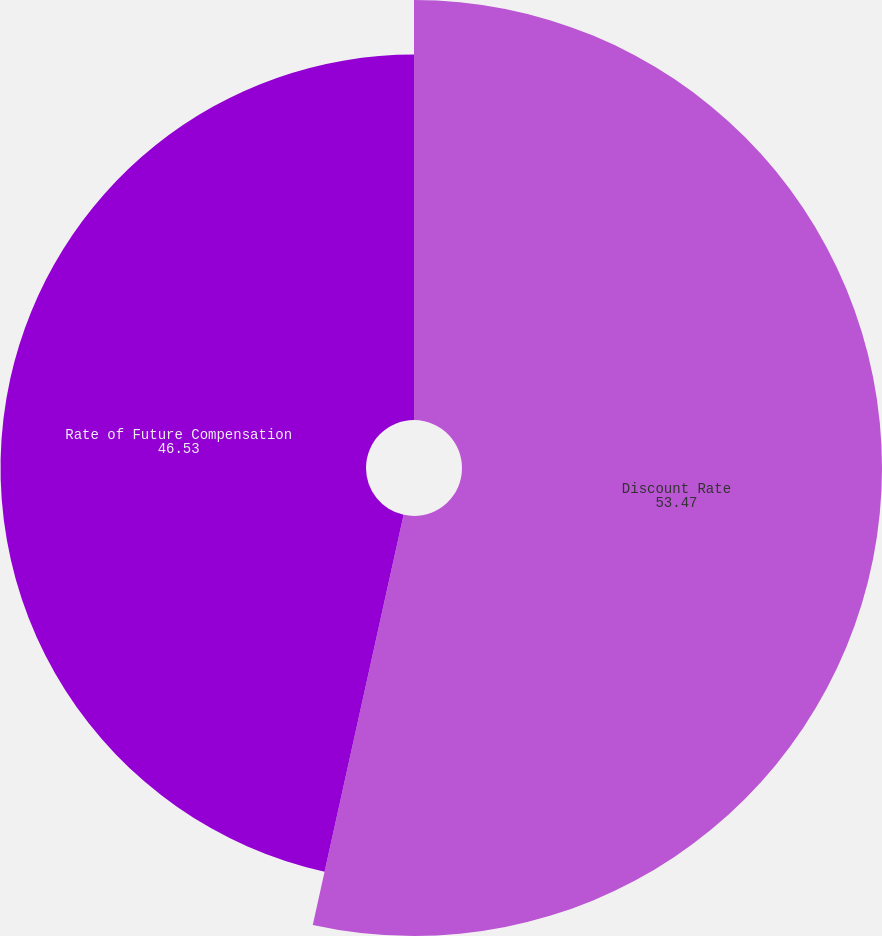<chart> <loc_0><loc_0><loc_500><loc_500><pie_chart><fcel>Discount Rate<fcel>Rate of Future Compensation<nl><fcel>53.47%<fcel>46.53%<nl></chart> 